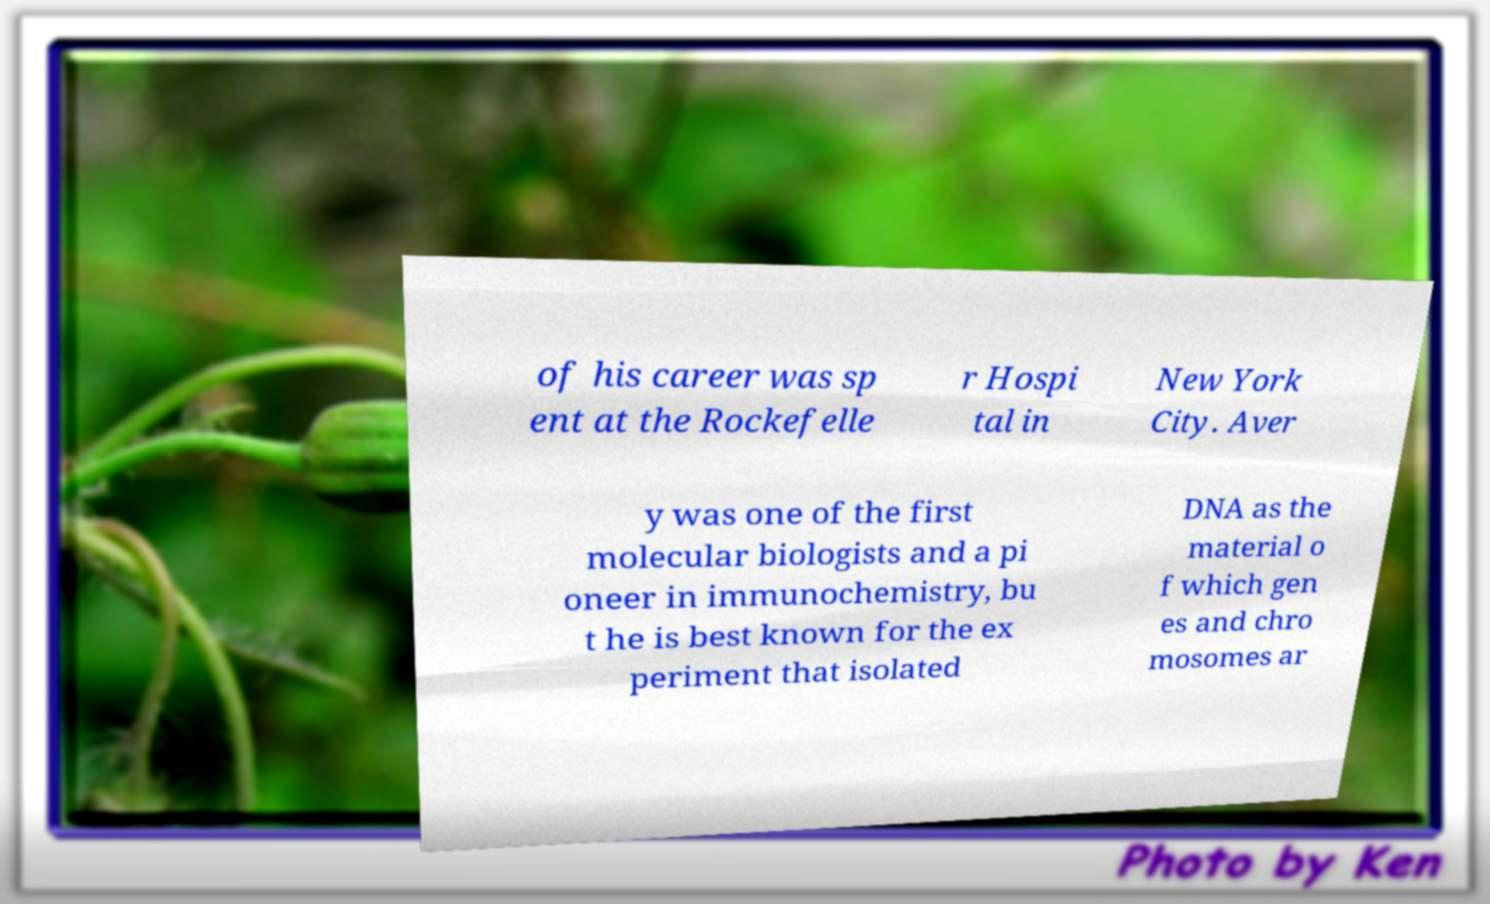Could you assist in decoding the text presented in this image and type it out clearly? of his career was sp ent at the Rockefelle r Hospi tal in New York City. Aver y was one of the first molecular biologists and a pi oneer in immunochemistry, bu t he is best known for the ex periment that isolated DNA as the material o f which gen es and chro mosomes ar 